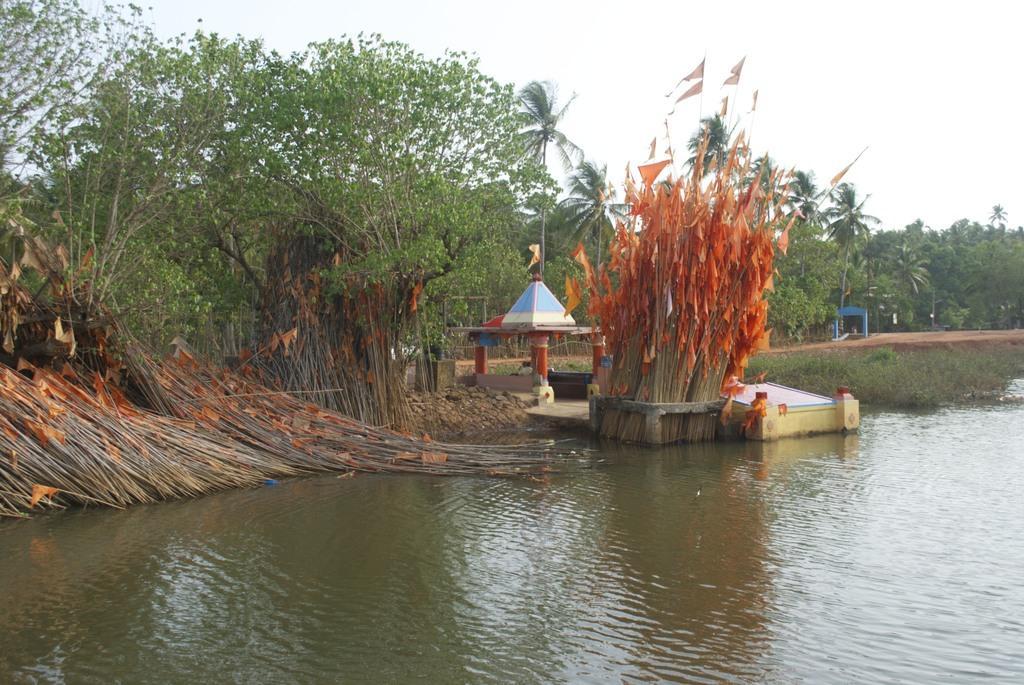In one or two sentences, can you explain what this image depicts? In this image there is a lake, in the background there are wooden sticks with flags and trees and a temple and the sky. 